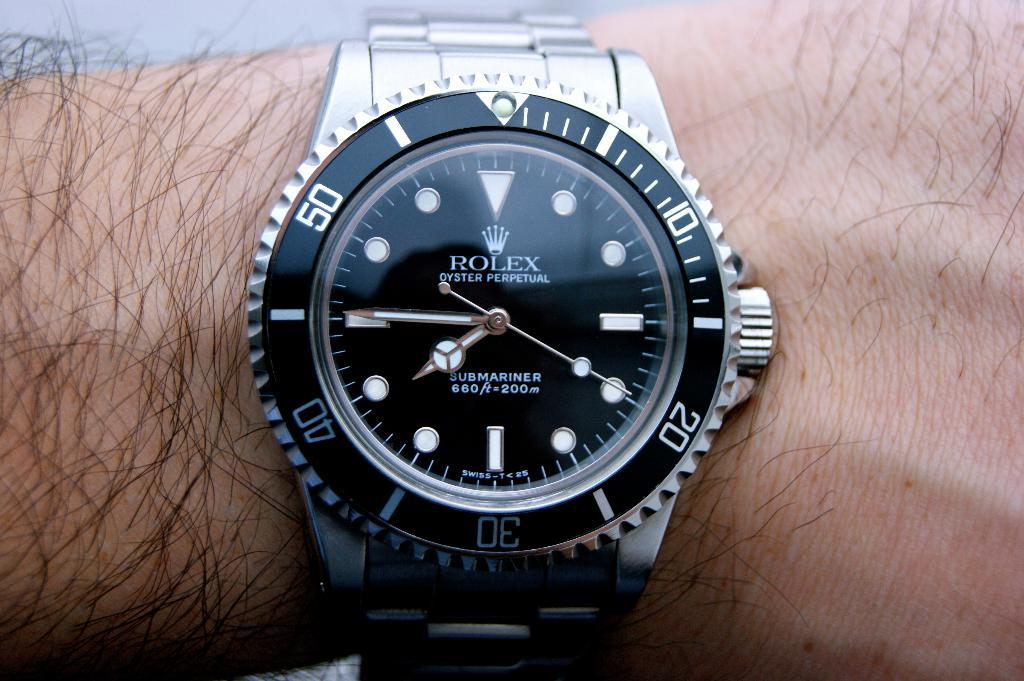<image>
Summarize the visual content of the image. Face watch which has the wrod ROLEX on it. 